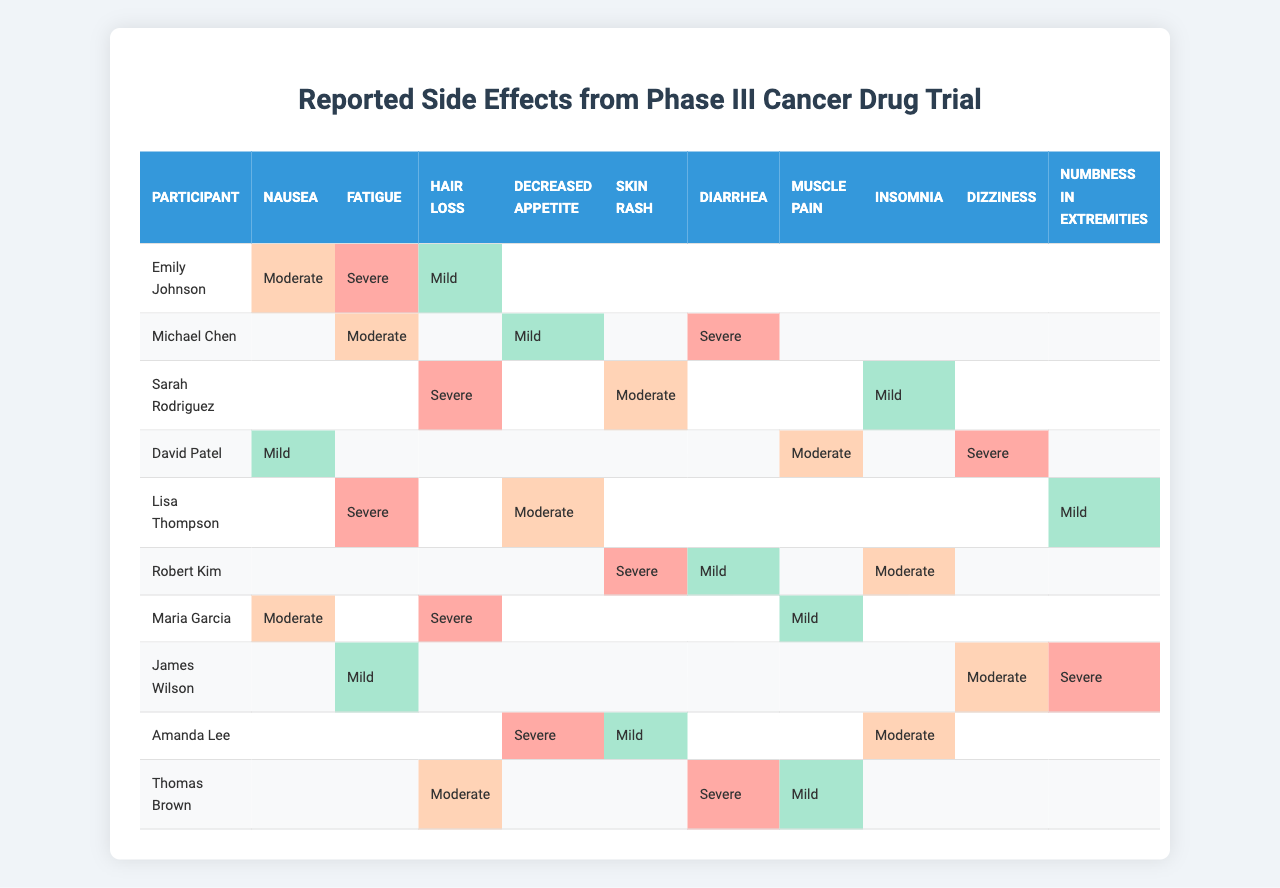What side effect did Emily Johnson report as severe? In the table, under Emily Johnson's row, the severe side effect is shown in the "Fatigue" column.
Answer: Fatigue Which participant reported both hair loss and nausea? In the table, Maria Garcia and Emily Johnson are listed under both hair loss and nausea. After reviewing each participant, it's clear that Maria Garcia and Emily Johnson reported these side effects.
Answer: Maria Garcia and Emily Johnson How many participants reported hair loss as a side effect? By checking each participant's data, we find that four participants reported hair loss: Emily Johnson, Sarah Rodriguez, Maria Garcia, and Thomas Brown. Hence, the total count is 4 participants.
Answer: 4 Did any participant report nausea as a mild side effect? Looking through the data in the table, David Patel reported nausea as a mild side effect.
Answer: Yes Which side effect had the highest severity reported and by whom? Scanning through the table for the highest severity, "Severe" is the peak level reported. Sarah Rodriguez and two others reported it, but with Sarah Rodriguez as a standout participant for hair loss.
Answer: Hair loss by Sarah Rodriguez What is the average severity level reported for fatigue among participants? The severity levels for fatigue include: Emily Johnson (Severe), Michael Chen (Moderate), Lisa Thompson (Severe), and James Wilson (Mild). In this context, we assign numerical values to severity: Mild = 1, Moderate = 2, Severe = 3. The calculation gives: (3 + 2 + 3 + 1) = 9. Dividing by the 4 reports yields an average severity of 2.25, which falls between Moderate and Severe.
Answer: 2.25 Did Robert Kim report any side effects as mild? Reviewing Robert Kim's entry shows that he reported diarrhea as mild. Therefore, the answer is yes.
Answer: Yes Which participant experienced dizziness as a severe side effect? The table indicates that David Patel reported dizziness with a severe designation under his row.
Answer: David Patel Compare the number of moderate and severe reports. Which is greater? Collectively, if we count the moderate and severe reports, we find moderates count is 7 and severes count is 6 across participants. That confirms moderate reports exceed severe.
Answer: Moderate is greater What percentage of participants reported fatigue as a side effect? Checking the data reveals that fatigue was reported by four out of the ten participants. To calculate the percentage, this follows: (4/10) * 100 = 40%.
Answer: 40% Which side effect was reported only once as severe? By checking each column of the table for the severity classification, we find that "Nausea" was reported only once as severe, by Emily Johnson.
Answer: Nausea 